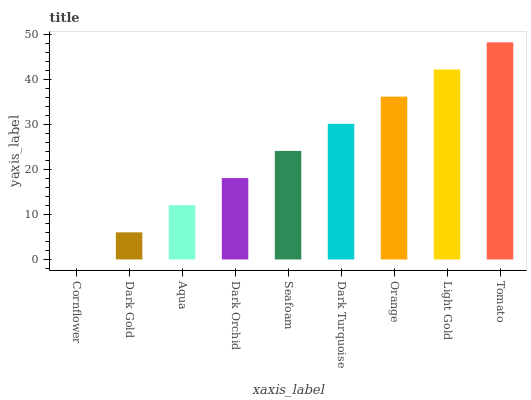Is Dark Gold the minimum?
Answer yes or no. No. Is Dark Gold the maximum?
Answer yes or no. No. Is Dark Gold greater than Cornflower?
Answer yes or no. Yes. Is Cornflower less than Dark Gold?
Answer yes or no. Yes. Is Cornflower greater than Dark Gold?
Answer yes or no. No. Is Dark Gold less than Cornflower?
Answer yes or no. No. Is Seafoam the high median?
Answer yes or no. Yes. Is Seafoam the low median?
Answer yes or no. Yes. Is Light Gold the high median?
Answer yes or no. No. Is Light Gold the low median?
Answer yes or no. No. 